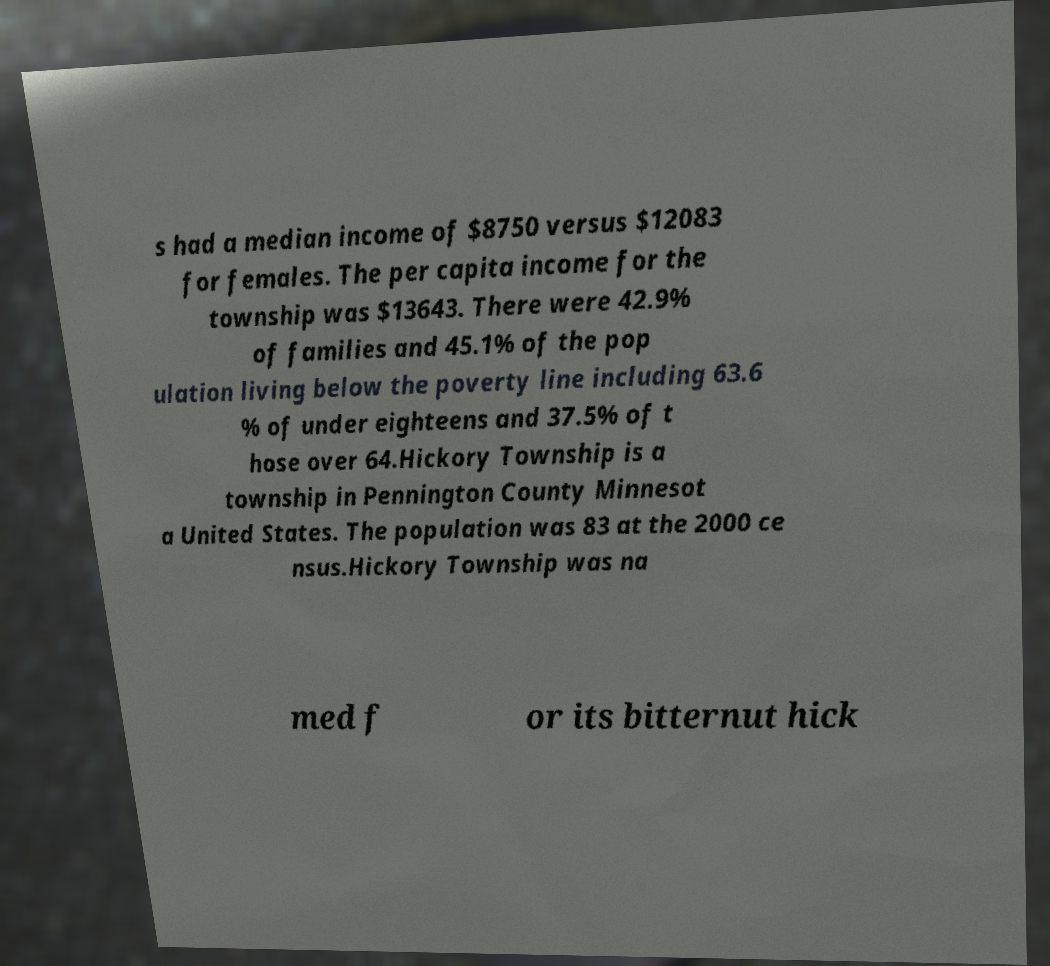What messages or text are displayed in this image? I need them in a readable, typed format. s had a median income of $8750 versus $12083 for females. The per capita income for the township was $13643. There were 42.9% of families and 45.1% of the pop ulation living below the poverty line including 63.6 % of under eighteens and 37.5% of t hose over 64.Hickory Township is a township in Pennington County Minnesot a United States. The population was 83 at the 2000 ce nsus.Hickory Township was na med f or its bitternut hick 